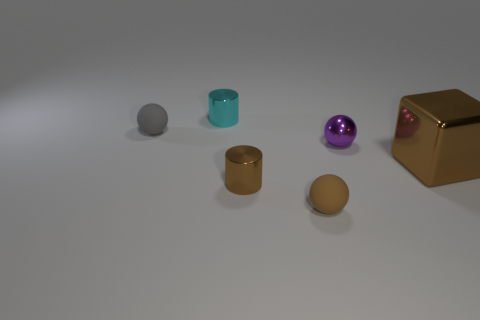Add 4 brown balls. How many objects exist? 10 Subtract all small metal spheres. How many spheres are left? 2 Subtract all cylinders. How many objects are left? 4 Add 1 small purple metallic things. How many small purple metallic things exist? 2 Subtract 0 blue cubes. How many objects are left? 6 Subtract all blue cylinders. Subtract all yellow spheres. How many cylinders are left? 2 Subtract all tiny brown balls. Subtract all gray rubber things. How many objects are left? 4 Add 3 matte objects. How many matte objects are left? 5 